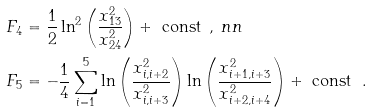Convert formula to latex. <formula><loc_0><loc_0><loc_500><loc_500>F _ { 4 } & = \frac { 1 } { 2 } \ln ^ { 2 } \left ( \frac { x _ { 1 3 } ^ { 2 } } { x _ { 2 4 } ^ { 2 } } \right ) + \text { const } \, , \ n n \\ F _ { 5 } & = - \frac { 1 } { 4 } \sum _ { i = 1 } ^ { 5 } \ln \left ( \frac { x _ { i , i + 2 } ^ { 2 } } { x _ { i , i + 3 } ^ { 2 } } \right ) \ln \left ( \frac { x _ { i + 1 , i + 3 } ^ { 2 } } { x _ { i + 2 , i + 4 } ^ { 2 } } \right ) + \text { const } \ .</formula> 